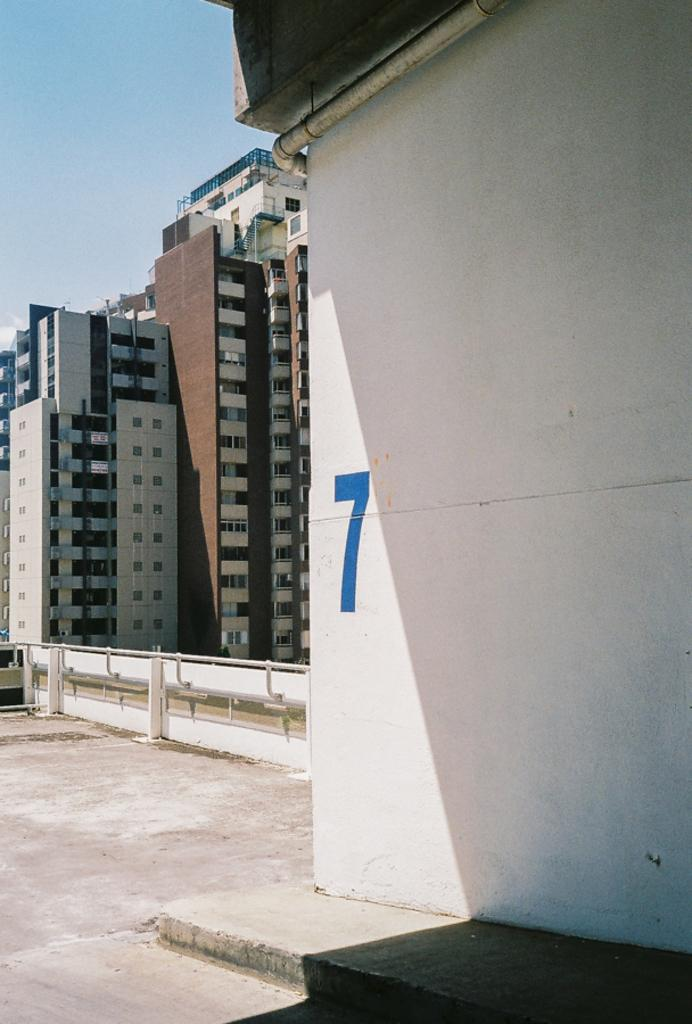What type of structures can be seen in the image? There are buildings in the image. How many dogs are visible in the image? There are no dogs present in the image; it only features buildings. What type of suggestion can be seen written on the side of the building? There is no suggestion visible on the side of the building in the image. What is the purpose of the needle in the image? There is no needle present in the image. 